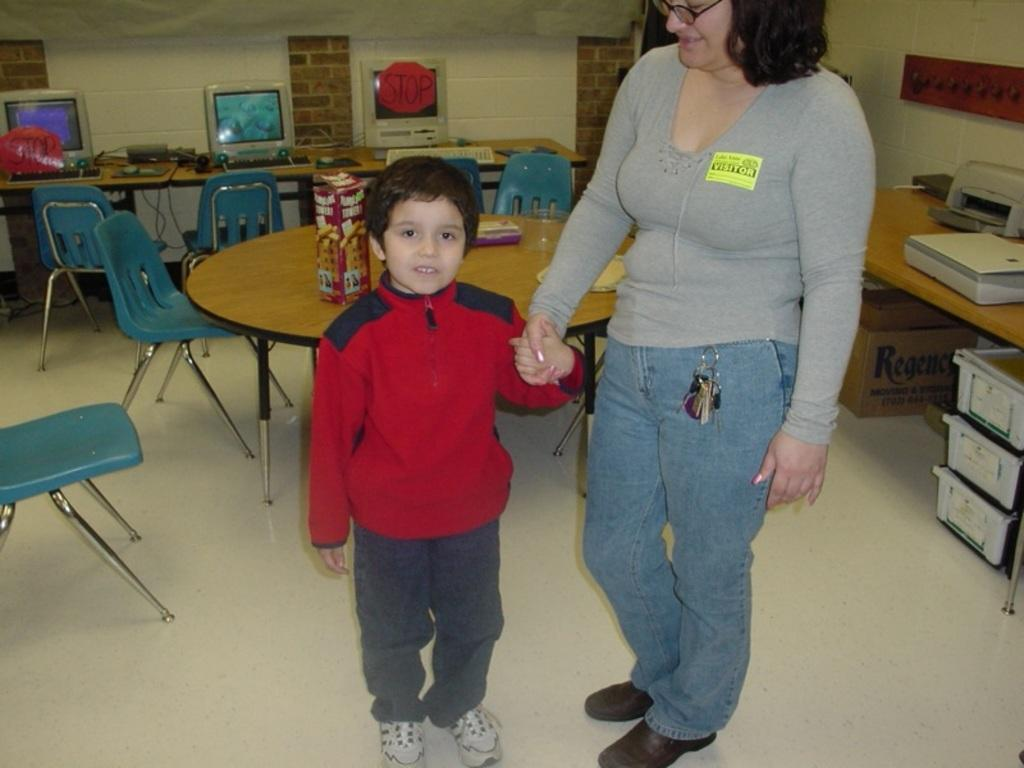Who is present in the image? There is a woman in the image. What is the woman doing in the image? The woman is holding the hand of a boy. Where are the woman and the boy standing? They are standing on the floor. What furniture can be seen in the image? There are chairs and a table in the image. What type of crow is sitting on the table in the image? There is no crow present in the image; it only features a woman, a boy, and furniture. Is there an umbrella visible in the image? No, there is no umbrella present in the image. 